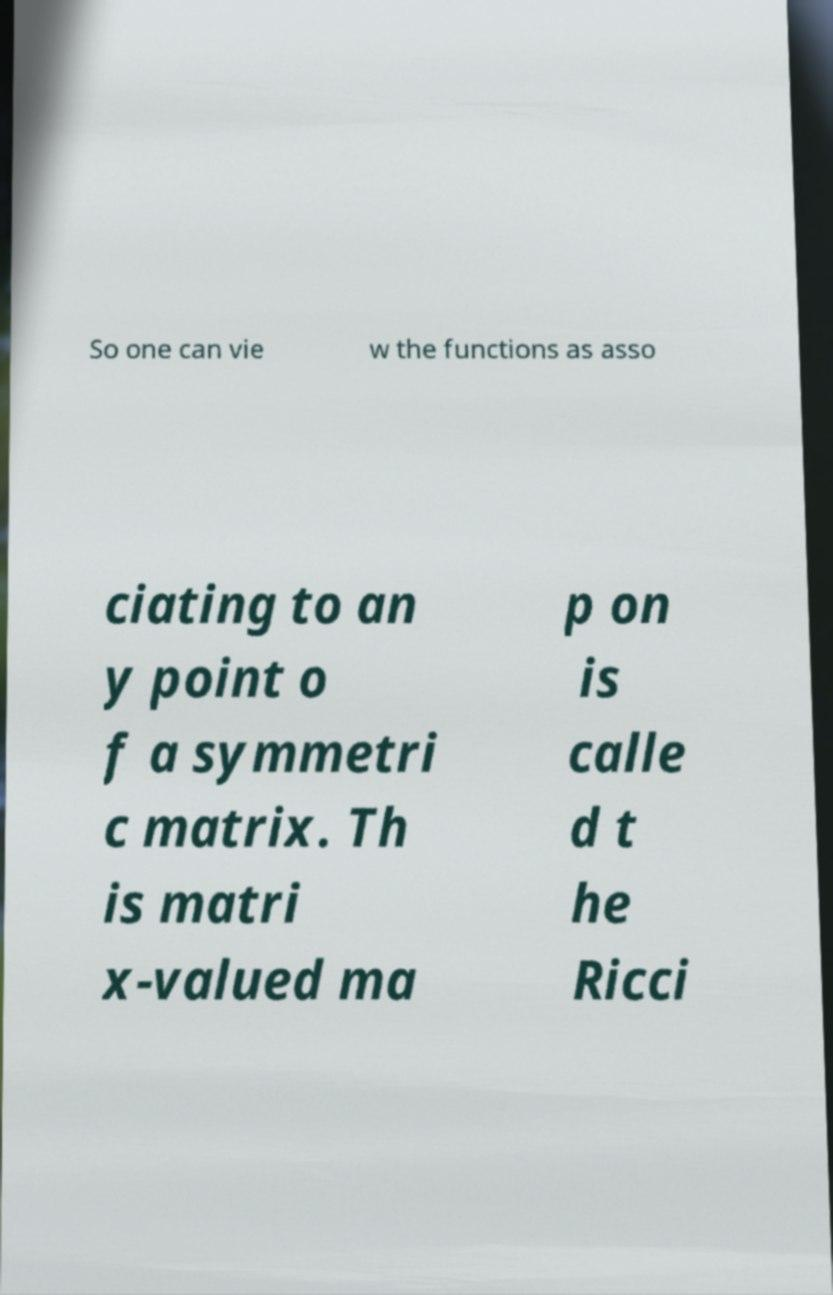Can you accurately transcribe the text from the provided image for me? So one can vie w the functions as asso ciating to an y point o f a symmetri c matrix. Th is matri x-valued ma p on is calle d t he Ricci 